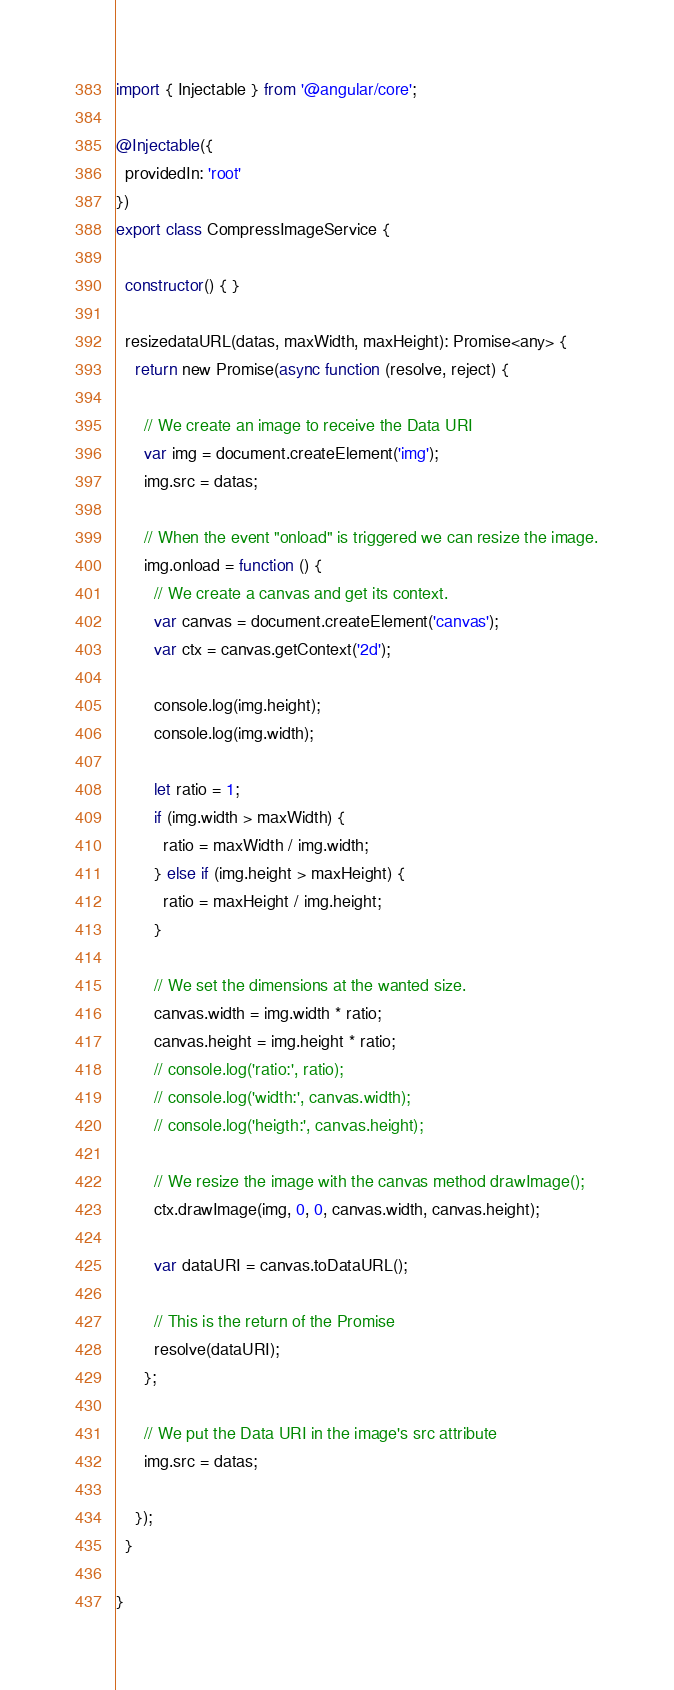<code> <loc_0><loc_0><loc_500><loc_500><_TypeScript_>import { Injectable } from '@angular/core';

@Injectable({
  providedIn: 'root'
})
export class CompressImageService {

  constructor() { }

  resizedataURL(datas, maxWidth, maxHeight): Promise<any> {
    return new Promise(async function (resolve, reject) {

      // We create an image to receive the Data URI
      var img = document.createElement('img');
      img.src = datas;

      // When the event "onload" is triggered we can resize the image.
      img.onload = function () {
        // We create a canvas and get its context.
        var canvas = document.createElement('canvas');
        var ctx = canvas.getContext('2d');

        console.log(img.height);
        console.log(img.width);

        let ratio = 1;
        if (img.width > maxWidth) {
          ratio = maxWidth / img.width;
        } else if (img.height > maxHeight) {
          ratio = maxHeight / img.height;
        }

        // We set the dimensions at the wanted size.
        canvas.width = img.width * ratio;
        canvas.height = img.height * ratio;
        // console.log('ratio:', ratio);
        // console.log('width:', canvas.width);
        // console.log('heigth:', canvas.height);

        // We resize the image with the canvas method drawImage();
        ctx.drawImage(img, 0, 0, canvas.width, canvas.height);

        var dataURI = canvas.toDataURL();

        // This is the return of the Promise
        resolve(dataURI);
      };

      // We put the Data URI in the image's src attribute
      img.src = datas;

    });
  }

}
</code> 